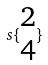Convert formula to latex. <formula><loc_0><loc_0><loc_500><loc_500>s \{ \begin{matrix} 2 \\ 4 \end{matrix} \}</formula> 